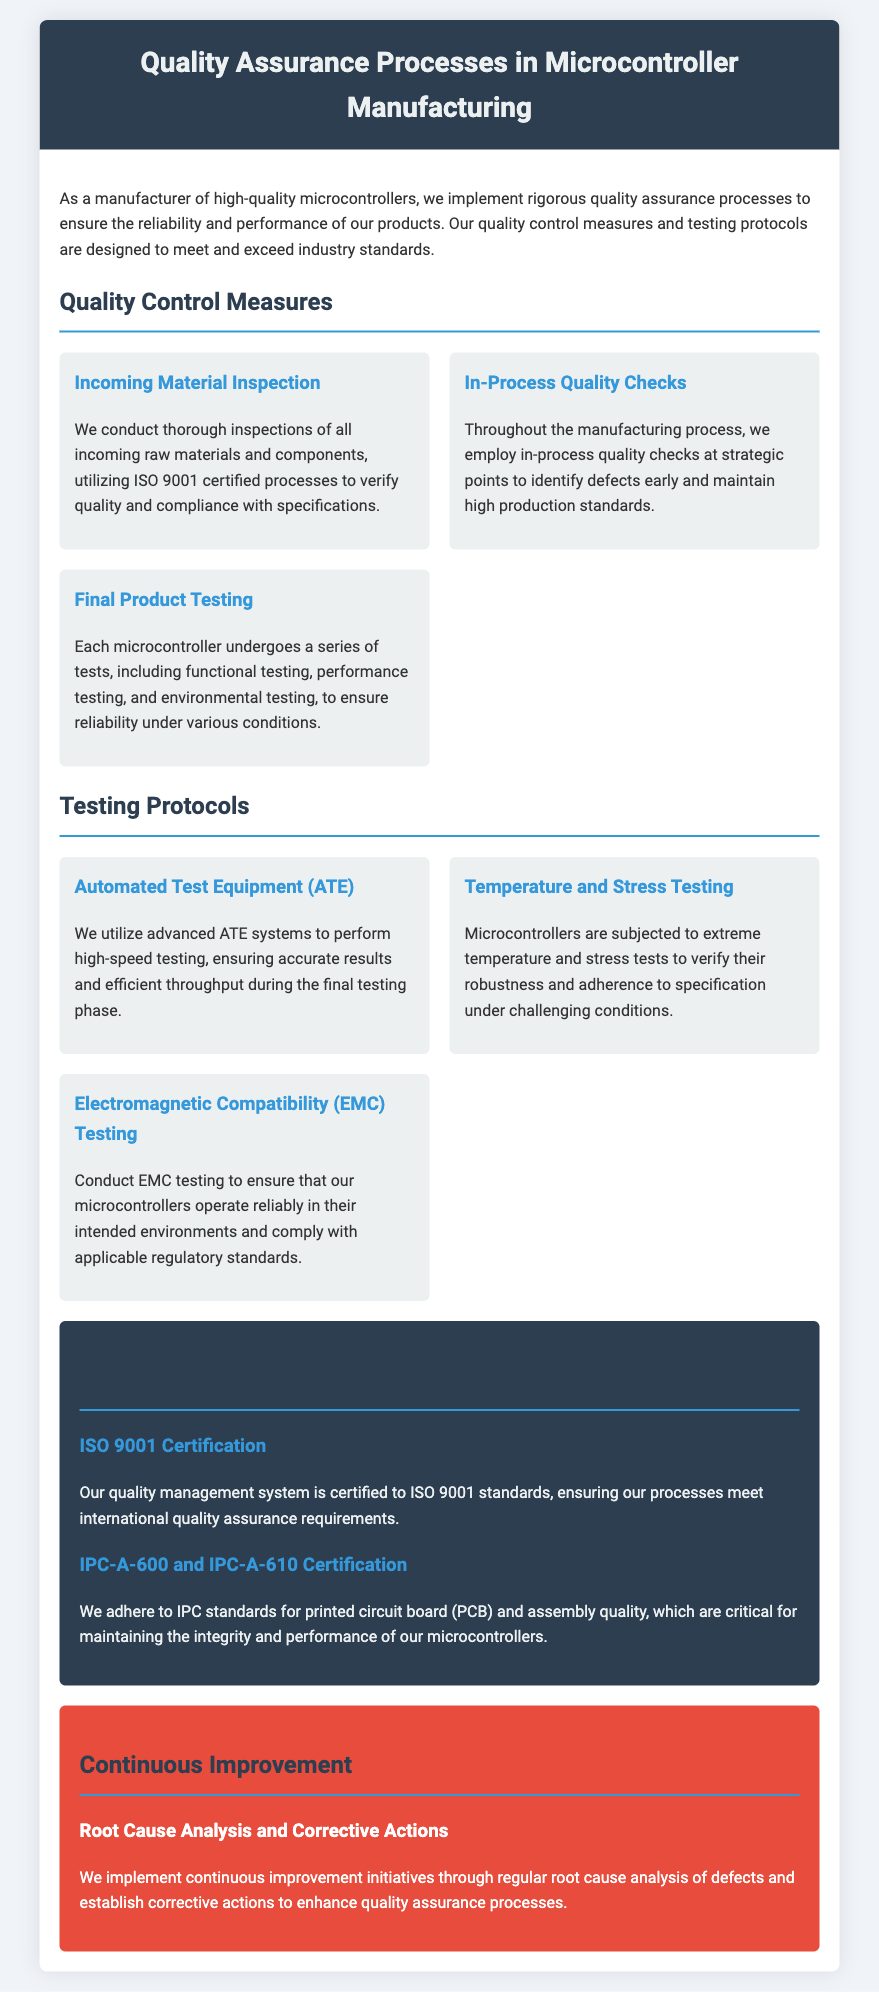what is the certification standard of the quality management system? The quality management system is certified to ISO 9001 standards, which is mentioned in the Certifications section.
Answer: ISO 9001 what type of testing is performed on microcontrollers? Each microcontroller undergoes functional testing, performance testing, and environmental testing as part of the final product testing.
Answer: Functional, performance, and environmental testing which phase uses Automated Test Equipment (ATE)? The Automated Test Equipment is utilized during the final testing phase to ensure accurate results and efficient throughput.
Answer: Final testing phase what is the focus of the Root Cause Analysis and Corrective Actions? This continuous improvement initiative aims to enhance quality assurance processes by analyzing defects and establishing corrective actions.
Answer: Enhance quality assurance processes how are raw materials inspected? Raw materials and components are subjected to thorough inspections utilizing ISO 9001 certified processes to verify quality and compliance.
Answer: ISO 9001 certified processes what type of testing verifies robustness under challenging conditions? Temperature and Stress Testing are specifically done to verify the robustness of microcontrollers under extreme conditions.
Answer: Temperature and Stress Testing what certifications related to PCB quality do they adhere to? The document mentions adherence to IPC-A-600 and IPC-A-610 standards for printed circuit board quality.
Answer: IPC-A-600 and IPC-A-610 what is the purpose of Electromagnetic Compatibility (EMC) Testing? EMC testing is conducted to ensure that microcontrollers operate reliably in their intended environments and comply with regulatory standards.
Answer: Ensure reliable operation and compliance how many quality control measures are listed? Three quality control measures are outlined: Incoming Material Inspection, In-Process Quality Checks, and Final Product Testing.
Answer: Three 